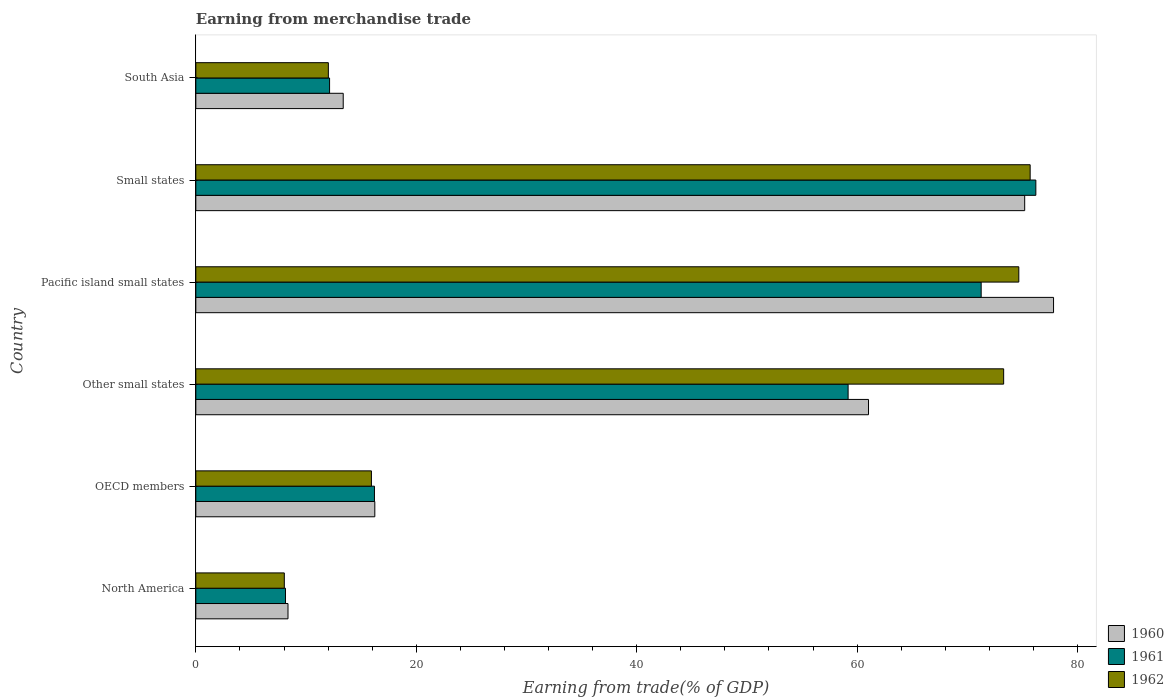How many groups of bars are there?
Give a very brief answer. 6. Are the number of bars per tick equal to the number of legend labels?
Ensure brevity in your answer.  Yes. How many bars are there on the 3rd tick from the top?
Ensure brevity in your answer.  3. What is the label of the 5th group of bars from the top?
Provide a succinct answer. OECD members. In how many cases, is the number of bars for a given country not equal to the number of legend labels?
Your answer should be very brief. 0. What is the earnings from trade in 1960 in North America?
Ensure brevity in your answer.  8.36. Across all countries, what is the maximum earnings from trade in 1962?
Keep it short and to the point. 75.7. Across all countries, what is the minimum earnings from trade in 1962?
Keep it short and to the point. 8.03. In which country was the earnings from trade in 1960 maximum?
Make the answer very short. Pacific island small states. In which country was the earnings from trade in 1960 minimum?
Offer a terse response. North America. What is the total earnings from trade in 1962 in the graph?
Offer a very short reply. 259.64. What is the difference between the earnings from trade in 1960 in North America and that in South Asia?
Ensure brevity in your answer.  -5.01. What is the difference between the earnings from trade in 1962 in Small states and the earnings from trade in 1960 in OECD members?
Provide a succinct answer. 59.46. What is the average earnings from trade in 1962 per country?
Offer a terse response. 43.27. What is the difference between the earnings from trade in 1960 and earnings from trade in 1961 in North America?
Your response must be concise. 0.23. In how many countries, is the earnings from trade in 1960 greater than 72 %?
Make the answer very short. 2. What is the ratio of the earnings from trade in 1962 in North America to that in South Asia?
Your answer should be very brief. 0.67. Is the earnings from trade in 1960 in Other small states less than that in South Asia?
Make the answer very short. No. What is the difference between the highest and the second highest earnings from trade in 1962?
Ensure brevity in your answer.  1.03. What is the difference between the highest and the lowest earnings from trade in 1960?
Give a very brief answer. 69.46. In how many countries, is the earnings from trade in 1962 greater than the average earnings from trade in 1962 taken over all countries?
Make the answer very short. 3. Is the sum of the earnings from trade in 1961 in Small states and South Asia greater than the maximum earnings from trade in 1962 across all countries?
Offer a terse response. Yes. What does the 3rd bar from the top in Pacific island small states represents?
Give a very brief answer. 1960. What is the difference between two consecutive major ticks on the X-axis?
Give a very brief answer. 20. Does the graph contain grids?
Provide a short and direct response. No. Where does the legend appear in the graph?
Make the answer very short. Bottom right. How many legend labels are there?
Give a very brief answer. 3. What is the title of the graph?
Your answer should be very brief. Earning from merchandise trade. What is the label or title of the X-axis?
Give a very brief answer. Earning from trade(% of GDP). What is the Earning from trade(% of GDP) of 1960 in North America?
Your response must be concise. 8.36. What is the Earning from trade(% of GDP) in 1961 in North America?
Offer a very short reply. 8.13. What is the Earning from trade(% of GDP) of 1962 in North America?
Make the answer very short. 8.03. What is the Earning from trade(% of GDP) of 1960 in OECD members?
Give a very brief answer. 16.24. What is the Earning from trade(% of GDP) in 1961 in OECD members?
Ensure brevity in your answer.  16.21. What is the Earning from trade(% of GDP) of 1962 in OECD members?
Give a very brief answer. 15.93. What is the Earning from trade(% of GDP) in 1960 in Other small states?
Make the answer very short. 61.03. What is the Earning from trade(% of GDP) of 1961 in Other small states?
Offer a terse response. 59.18. What is the Earning from trade(% of GDP) in 1962 in Other small states?
Ensure brevity in your answer.  73.29. What is the Earning from trade(% of GDP) of 1960 in Pacific island small states?
Provide a succinct answer. 77.82. What is the Earning from trade(% of GDP) of 1961 in Pacific island small states?
Ensure brevity in your answer.  71.25. What is the Earning from trade(% of GDP) in 1962 in Pacific island small states?
Make the answer very short. 74.67. What is the Earning from trade(% of GDP) of 1960 in Small states?
Keep it short and to the point. 75.2. What is the Earning from trade(% of GDP) of 1961 in Small states?
Provide a short and direct response. 76.21. What is the Earning from trade(% of GDP) of 1962 in Small states?
Your answer should be compact. 75.7. What is the Earning from trade(% of GDP) in 1960 in South Asia?
Offer a terse response. 13.37. What is the Earning from trade(% of GDP) of 1961 in South Asia?
Give a very brief answer. 12.14. What is the Earning from trade(% of GDP) of 1962 in South Asia?
Your response must be concise. 12.02. Across all countries, what is the maximum Earning from trade(% of GDP) in 1960?
Make the answer very short. 77.82. Across all countries, what is the maximum Earning from trade(% of GDP) in 1961?
Offer a very short reply. 76.21. Across all countries, what is the maximum Earning from trade(% of GDP) of 1962?
Offer a very short reply. 75.7. Across all countries, what is the minimum Earning from trade(% of GDP) of 1960?
Offer a terse response. 8.36. Across all countries, what is the minimum Earning from trade(% of GDP) in 1961?
Offer a terse response. 8.13. Across all countries, what is the minimum Earning from trade(% of GDP) in 1962?
Ensure brevity in your answer.  8.03. What is the total Earning from trade(% of GDP) of 1960 in the graph?
Ensure brevity in your answer.  252.03. What is the total Earning from trade(% of GDP) of 1961 in the graph?
Provide a short and direct response. 243.12. What is the total Earning from trade(% of GDP) in 1962 in the graph?
Your answer should be very brief. 259.64. What is the difference between the Earning from trade(% of GDP) in 1960 in North America and that in OECD members?
Give a very brief answer. -7.88. What is the difference between the Earning from trade(% of GDP) in 1961 in North America and that in OECD members?
Provide a succinct answer. -8.07. What is the difference between the Earning from trade(% of GDP) in 1962 in North America and that in OECD members?
Your answer should be compact. -7.9. What is the difference between the Earning from trade(% of GDP) of 1960 in North America and that in Other small states?
Provide a short and direct response. -52.67. What is the difference between the Earning from trade(% of GDP) of 1961 in North America and that in Other small states?
Your response must be concise. -51.05. What is the difference between the Earning from trade(% of GDP) of 1962 in North America and that in Other small states?
Provide a succinct answer. -65.27. What is the difference between the Earning from trade(% of GDP) of 1960 in North America and that in Pacific island small states?
Your answer should be very brief. -69.46. What is the difference between the Earning from trade(% of GDP) in 1961 in North America and that in Pacific island small states?
Your answer should be very brief. -63.12. What is the difference between the Earning from trade(% of GDP) of 1962 in North America and that in Pacific island small states?
Keep it short and to the point. -66.64. What is the difference between the Earning from trade(% of GDP) in 1960 in North America and that in Small states?
Keep it short and to the point. -66.84. What is the difference between the Earning from trade(% of GDP) in 1961 in North America and that in Small states?
Keep it short and to the point. -68.08. What is the difference between the Earning from trade(% of GDP) of 1962 in North America and that in Small states?
Make the answer very short. -67.67. What is the difference between the Earning from trade(% of GDP) of 1960 in North America and that in South Asia?
Your answer should be very brief. -5.01. What is the difference between the Earning from trade(% of GDP) of 1961 in North America and that in South Asia?
Offer a very short reply. -4. What is the difference between the Earning from trade(% of GDP) in 1962 in North America and that in South Asia?
Provide a succinct answer. -4. What is the difference between the Earning from trade(% of GDP) in 1960 in OECD members and that in Other small states?
Provide a short and direct response. -44.79. What is the difference between the Earning from trade(% of GDP) of 1961 in OECD members and that in Other small states?
Make the answer very short. -42.98. What is the difference between the Earning from trade(% of GDP) in 1962 in OECD members and that in Other small states?
Provide a short and direct response. -57.36. What is the difference between the Earning from trade(% of GDP) in 1960 in OECD members and that in Pacific island small states?
Your answer should be compact. -61.58. What is the difference between the Earning from trade(% of GDP) of 1961 in OECD members and that in Pacific island small states?
Your response must be concise. -55.05. What is the difference between the Earning from trade(% of GDP) in 1962 in OECD members and that in Pacific island small states?
Ensure brevity in your answer.  -58.74. What is the difference between the Earning from trade(% of GDP) in 1960 in OECD members and that in Small states?
Your answer should be compact. -58.96. What is the difference between the Earning from trade(% of GDP) in 1961 in OECD members and that in Small states?
Offer a very short reply. -60.01. What is the difference between the Earning from trade(% of GDP) in 1962 in OECD members and that in Small states?
Your response must be concise. -59.77. What is the difference between the Earning from trade(% of GDP) in 1960 in OECD members and that in South Asia?
Provide a short and direct response. 2.87. What is the difference between the Earning from trade(% of GDP) in 1961 in OECD members and that in South Asia?
Give a very brief answer. 4.07. What is the difference between the Earning from trade(% of GDP) in 1962 in OECD members and that in South Asia?
Offer a terse response. 3.91. What is the difference between the Earning from trade(% of GDP) in 1960 in Other small states and that in Pacific island small states?
Your response must be concise. -16.79. What is the difference between the Earning from trade(% of GDP) in 1961 in Other small states and that in Pacific island small states?
Offer a very short reply. -12.07. What is the difference between the Earning from trade(% of GDP) of 1962 in Other small states and that in Pacific island small states?
Provide a succinct answer. -1.37. What is the difference between the Earning from trade(% of GDP) in 1960 in Other small states and that in Small states?
Your answer should be very brief. -14.17. What is the difference between the Earning from trade(% of GDP) of 1961 in Other small states and that in Small states?
Provide a short and direct response. -17.03. What is the difference between the Earning from trade(% of GDP) of 1962 in Other small states and that in Small states?
Give a very brief answer. -2.4. What is the difference between the Earning from trade(% of GDP) in 1960 in Other small states and that in South Asia?
Offer a very short reply. 47.66. What is the difference between the Earning from trade(% of GDP) in 1961 in Other small states and that in South Asia?
Provide a short and direct response. 47.05. What is the difference between the Earning from trade(% of GDP) of 1962 in Other small states and that in South Asia?
Provide a succinct answer. 61.27. What is the difference between the Earning from trade(% of GDP) of 1960 in Pacific island small states and that in Small states?
Your answer should be compact. 2.62. What is the difference between the Earning from trade(% of GDP) in 1961 in Pacific island small states and that in Small states?
Make the answer very short. -4.96. What is the difference between the Earning from trade(% of GDP) of 1962 in Pacific island small states and that in Small states?
Your answer should be very brief. -1.03. What is the difference between the Earning from trade(% of GDP) in 1960 in Pacific island small states and that in South Asia?
Your response must be concise. 64.45. What is the difference between the Earning from trade(% of GDP) in 1961 in Pacific island small states and that in South Asia?
Offer a terse response. 59.12. What is the difference between the Earning from trade(% of GDP) in 1962 in Pacific island small states and that in South Asia?
Your answer should be very brief. 62.64. What is the difference between the Earning from trade(% of GDP) of 1960 in Small states and that in South Asia?
Offer a terse response. 61.83. What is the difference between the Earning from trade(% of GDP) of 1961 in Small states and that in South Asia?
Keep it short and to the point. 64.08. What is the difference between the Earning from trade(% of GDP) of 1962 in Small states and that in South Asia?
Offer a very short reply. 63.67. What is the difference between the Earning from trade(% of GDP) in 1960 in North America and the Earning from trade(% of GDP) in 1961 in OECD members?
Offer a terse response. -7.84. What is the difference between the Earning from trade(% of GDP) in 1960 in North America and the Earning from trade(% of GDP) in 1962 in OECD members?
Your answer should be compact. -7.57. What is the difference between the Earning from trade(% of GDP) in 1961 in North America and the Earning from trade(% of GDP) in 1962 in OECD members?
Keep it short and to the point. -7.8. What is the difference between the Earning from trade(% of GDP) in 1960 in North America and the Earning from trade(% of GDP) in 1961 in Other small states?
Your answer should be compact. -50.82. What is the difference between the Earning from trade(% of GDP) in 1960 in North America and the Earning from trade(% of GDP) in 1962 in Other small states?
Provide a succinct answer. -64.93. What is the difference between the Earning from trade(% of GDP) in 1961 in North America and the Earning from trade(% of GDP) in 1962 in Other small states?
Provide a succinct answer. -65.16. What is the difference between the Earning from trade(% of GDP) in 1960 in North America and the Earning from trade(% of GDP) in 1961 in Pacific island small states?
Make the answer very short. -62.89. What is the difference between the Earning from trade(% of GDP) of 1960 in North America and the Earning from trade(% of GDP) of 1962 in Pacific island small states?
Your answer should be compact. -66.31. What is the difference between the Earning from trade(% of GDP) in 1961 in North America and the Earning from trade(% of GDP) in 1962 in Pacific island small states?
Keep it short and to the point. -66.53. What is the difference between the Earning from trade(% of GDP) of 1960 in North America and the Earning from trade(% of GDP) of 1961 in Small states?
Offer a very short reply. -67.85. What is the difference between the Earning from trade(% of GDP) in 1960 in North America and the Earning from trade(% of GDP) in 1962 in Small states?
Provide a short and direct response. -67.33. What is the difference between the Earning from trade(% of GDP) in 1961 in North America and the Earning from trade(% of GDP) in 1962 in Small states?
Give a very brief answer. -67.56. What is the difference between the Earning from trade(% of GDP) in 1960 in North America and the Earning from trade(% of GDP) in 1961 in South Asia?
Your answer should be compact. -3.77. What is the difference between the Earning from trade(% of GDP) of 1960 in North America and the Earning from trade(% of GDP) of 1962 in South Asia?
Offer a very short reply. -3.66. What is the difference between the Earning from trade(% of GDP) of 1961 in North America and the Earning from trade(% of GDP) of 1962 in South Asia?
Keep it short and to the point. -3.89. What is the difference between the Earning from trade(% of GDP) in 1960 in OECD members and the Earning from trade(% of GDP) in 1961 in Other small states?
Make the answer very short. -42.94. What is the difference between the Earning from trade(% of GDP) of 1960 in OECD members and the Earning from trade(% of GDP) of 1962 in Other small states?
Offer a terse response. -57.05. What is the difference between the Earning from trade(% of GDP) in 1961 in OECD members and the Earning from trade(% of GDP) in 1962 in Other small states?
Your answer should be compact. -57.09. What is the difference between the Earning from trade(% of GDP) in 1960 in OECD members and the Earning from trade(% of GDP) in 1961 in Pacific island small states?
Keep it short and to the point. -55.01. What is the difference between the Earning from trade(% of GDP) of 1960 in OECD members and the Earning from trade(% of GDP) of 1962 in Pacific island small states?
Make the answer very short. -58.43. What is the difference between the Earning from trade(% of GDP) in 1961 in OECD members and the Earning from trade(% of GDP) in 1962 in Pacific island small states?
Ensure brevity in your answer.  -58.46. What is the difference between the Earning from trade(% of GDP) in 1960 in OECD members and the Earning from trade(% of GDP) in 1961 in Small states?
Make the answer very short. -59.97. What is the difference between the Earning from trade(% of GDP) of 1960 in OECD members and the Earning from trade(% of GDP) of 1962 in Small states?
Keep it short and to the point. -59.46. What is the difference between the Earning from trade(% of GDP) of 1961 in OECD members and the Earning from trade(% of GDP) of 1962 in Small states?
Offer a very short reply. -59.49. What is the difference between the Earning from trade(% of GDP) of 1960 in OECD members and the Earning from trade(% of GDP) of 1961 in South Asia?
Provide a short and direct response. 4.1. What is the difference between the Earning from trade(% of GDP) of 1960 in OECD members and the Earning from trade(% of GDP) of 1962 in South Asia?
Your answer should be compact. 4.22. What is the difference between the Earning from trade(% of GDP) of 1961 in OECD members and the Earning from trade(% of GDP) of 1962 in South Asia?
Provide a succinct answer. 4.18. What is the difference between the Earning from trade(% of GDP) of 1960 in Other small states and the Earning from trade(% of GDP) of 1961 in Pacific island small states?
Your answer should be compact. -10.22. What is the difference between the Earning from trade(% of GDP) of 1960 in Other small states and the Earning from trade(% of GDP) of 1962 in Pacific island small states?
Your answer should be very brief. -13.64. What is the difference between the Earning from trade(% of GDP) in 1961 in Other small states and the Earning from trade(% of GDP) in 1962 in Pacific island small states?
Your answer should be compact. -15.49. What is the difference between the Earning from trade(% of GDP) of 1960 in Other small states and the Earning from trade(% of GDP) of 1961 in Small states?
Give a very brief answer. -15.18. What is the difference between the Earning from trade(% of GDP) in 1960 in Other small states and the Earning from trade(% of GDP) in 1962 in Small states?
Your answer should be very brief. -14.67. What is the difference between the Earning from trade(% of GDP) of 1961 in Other small states and the Earning from trade(% of GDP) of 1962 in Small states?
Provide a short and direct response. -16.52. What is the difference between the Earning from trade(% of GDP) of 1960 in Other small states and the Earning from trade(% of GDP) of 1961 in South Asia?
Make the answer very short. 48.9. What is the difference between the Earning from trade(% of GDP) of 1960 in Other small states and the Earning from trade(% of GDP) of 1962 in South Asia?
Your answer should be compact. 49.01. What is the difference between the Earning from trade(% of GDP) in 1961 in Other small states and the Earning from trade(% of GDP) in 1962 in South Asia?
Your answer should be compact. 47.16. What is the difference between the Earning from trade(% of GDP) in 1960 in Pacific island small states and the Earning from trade(% of GDP) in 1961 in Small states?
Give a very brief answer. 1.61. What is the difference between the Earning from trade(% of GDP) in 1960 in Pacific island small states and the Earning from trade(% of GDP) in 1962 in Small states?
Make the answer very short. 2.12. What is the difference between the Earning from trade(% of GDP) in 1961 in Pacific island small states and the Earning from trade(% of GDP) in 1962 in Small states?
Ensure brevity in your answer.  -4.44. What is the difference between the Earning from trade(% of GDP) of 1960 in Pacific island small states and the Earning from trade(% of GDP) of 1961 in South Asia?
Offer a very short reply. 65.68. What is the difference between the Earning from trade(% of GDP) of 1960 in Pacific island small states and the Earning from trade(% of GDP) of 1962 in South Asia?
Your answer should be compact. 65.8. What is the difference between the Earning from trade(% of GDP) in 1961 in Pacific island small states and the Earning from trade(% of GDP) in 1962 in South Asia?
Make the answer very short. 59.23. What is the difference between the Earning from trade(% of GDP) of 1960 in Small states and the Earning from trade(% of GDP) of 1961 in South Asia?
Offer a very short reply. 63.07. What is the difference between the Earning from trade(% of GDP) of 1960 in Small states and the Earning from trade(% of GDP) of 1962 in South Asia?
Your answer should be very brief. 63.18. What is the difference between the Earning from trade(% of GDP) in 1961 in Small states and the Earning from trade(% of GDP) in 1962 in South Asia?
Provide a short and direct response. 64.19. What is the average Earning from trade(% of GDP) of 1960 per country?
Provide a short and direct response. 42. What is the average Earning from trade(% of GDP) in 1961 per country?
Your response must be concise. 40.52. What is the average Earning from trade(% of GDP) of 1962 per country?
Offer a terse response. 43.27. What is the difference between the Earning from trade(% of GDP) in 1960 and Earning from trade(% of GDP) in 1961 in North America?
Make the answer very short. 0.23. What is the difference between the Earning from trade(% of GDP) of 1960 and Earning from trade(% of GDP) of 1962 in North America?
Provide a succinct answer. 0.33. What is the difference between the Earning from trade(% of GDP) in 1961 and Earning from trade(% of GDP) in 1962 in North America?
Provide a succinct answer. 0.11. What is the difference between the Earning from trade(% of GDP) of 1960 and Earning from trade(% of GDP) of 1961 in OECD members?
Offer a terse response. 0.03. What is the difference between the Earning from trade(% of GDP) in 1960 and Earning from trade(% of GDP) in 1962 in OECD members?
Give a very brief answer. 0.31. What is the difference between the Earning from trade(% of GDP) in 1961 and Earning from trade(% of GDP) in 1962 in OECD members?
Offer a very short reply. 0.28. What is the difference between the Earning from trade(% of GDP) of 1960 and Earning from trade(% of GDP) of 1961 in Other small states?
Keep it short and to the point. 1.85. What is the difference between the Earning from trade(% of GDP) of 1960 and Earning from trade(% of GDP) of 1962 in Other small states?
Offer a terse response. -12.26. What is the difference between the Earning from trade(% of GDP) in 1961 and Earning from trade(% of GDP) in 1962 in Other small states?
Your answer should be compact. -14.11. What is the difference between the Earning from trade(% of GDP) in 1960 and Earning from trade(% of GDP) in 1961 in Pacific island small states?
Provide a succinct answer. 6.57. What is the difference between the Earning from trade(% of GDP) in 1960 and Earning from trade(% of GDP) in 1962 in Pacific island small states?
Provide a short and direct response. 3.15. What is the difference between the Earning from trade(% of GDP) of 1961 and Earning from trade(% of GDP) of 1962 in Pacific island small states?
Keep it short and to the point. -3.42. What is the difference between the Earning from trade(% of GDP) of 1960 and Earning from trade(% of GDP) of 1961 in Small states?
Your answer should be very brief. -1.01. What is the difference between the Earning from trade(% of GDP) in 1960 and Earning from trade(% of GDP) in 1962 in Small states?
Offer a terse response. -0.5. What is the difference between the Earning from trade(% of GDP) in 1961 and Earning from trade(% of GDP) in 1962 in Small states?
Make the answer very short. 0.52. What is the difference between the Earning from trade(% of GDP) in 1960 and Earning from trade(% of GDP) in 1961 in South Asia?
Provide a short and direct response. 1.24. What is the difference between the Earning from trade(% of GDP) in 1960 and Earning from trade(% of GDP) in 1962 in South Asia?
Offer a terse response. 1.35. What is the difference between the Earning from trade(% of GDP) of 1961 and Earning from trade(% of GDP) of 1962 in South Asia?
Ensure brevity in your answer.  0.11. What is the ratio of the Earning from trade(% of GDP) of 1960 in North America to that in OECD members?
Your answer should be compact. 0.52. What is the ratio of the Earning from trade(% of GDP) of 1961 in North America to that in OECD members?
Keep it short and to the point. 0.5. What is the ratio of the Earning from trade(% of GDP) in 1962 in North America to that in OECD members?
Your response must be concise. 0.5. What is the ratio of the Earning from trade(% of GDP) in 1960 in North America to that in Other small states?
Your answer should be very brief. 0.14. What is the ratio of the Earning from trade(% of GDP) in 1961 in North America to that in Other small states?
Your answer should be compact. 0.14. What is the ratio of the Earning from trade(% of GDP) in 1962 in North America to that in Other small states?
Keep it short and to the point. 0.11. What is the ratio of the Earning from trade(% of GDP) of 1960 in North America to that in Pacific island small states?
Your answer should be compact. 0.11. What is the ratio of the Earning from trade(% of GDP) in 1961 in North America to that in Pacific island small states?
Your response must be concise. 0.11. What is the ratio of the Earning from trade(% of GDP) in 1962 in North America to that in Pacific island small states?
Offer a terse response. 0.11. What is the ratio of the Earning from trade(% of GDP) in 1960 in North America to that in Small states?
Provide a succinct answer. 0.11. What is the ratio of the Earning from trade(% of GDP) in 1961 in North America to that in Small states?
Give a very brief answer. 0.11. What is the ratio of the Earning from trade(% of GDP) in 1962 in North America to that in Small states?
Provide a succinct answer. 0.11. What is the ratio of the Earning from trade(% of GDP) in 1960 in North America to that in South Asia?
Keep it short and to the point. 0.63. What is the ratio of the Earning from trade(% of GDP) of 1961 in North America to that in South Asia?
Offer a terse response. 0.67. What is the ratio of the Earning from trade(% of GDP) in 1962 in North America to that in South Asia?
Your answer should be compact. 0.67. What is the ratio of the Earning from trade(% of GDP) in 1960 in OECD members to that in Other small states?
Offer a terse response. 0.27. What is the ratio of the Earning from trade(% of GDP) of 1961 in OECD members to that in Other small states?
Offer a very short reply. 0.27. What is the ratio of the Earning from trade(% of GDP) in 1962 in OECD members to that in Other small states?
Offer a terse response. 0.22. What is the ratio of the Earning from trade(% of GDP) in 1960 in OECD members to that in Pacific island small states?
Keep it short and to the point. 0.21. What is the ratio of the Earning from trade(% of GDP) in 1961 in OECD members to that in Pacific island small states?
Give a very brief answer. 0.23. What is the ratio of the Earning from trade(% of GDP) in 1962 in OECD members to that in Pacific island small states?
Ensure brevity in your answer.  0.21. What is the ratio of the Earning from trade(% of GDP) in 1960 in OECD members to that in Small states?
Provide a succinct answer. 0.22. What is the ratio of the Earning from trade(% of GDP) of 1961 in OECD members to that in Small states?
Your answer should be very brief. 0.21. What is the ratio of the Earning from trade(% of GDP) in 1962 in OECD members to that in Small states?
Offer a very short reply. 0.21. What is the ratio of the Earning from trade(% of GDP) of 1960 in OECD members to that in South Asia?
Give a very brief answer. 1.21. What is the ratio of the Earning from trade(% of GDP) of 1961 in OECD members to that in South Asia?
Give a very brief answer. 1.34. What is the ratio of the Earning from trade(% of GDP) in 1962 in OECD members to that in South Asia?
Ensure brevity in your answer.  1.32. What is the ratio of the Earning from trade(% of GDP) in 1960 in Other small states to that in Pacific island small states?
Give a very brief answer. 0.78. What is the ratio of the Earning from trade(% of GDP) in 1961 in Other small states to that in Pacific island small states?
Your response must be concise. 0.83. What is the ratio of the Earning from trade(% of GDP) in 1962 in Other small states to that in Pacific island small states?
Offer a very short reply. 0.98. What is the ratio of the Earning from trade(% of GDP) in 1960 in Other small states to that in Small states?
Give a very brief answer. 0.81. What is the ratio of the Earning from trade(% of GDP) of 1961 in Other small states to that in Small states?
Your answer should be compact. 0.78. What is the ratio of the Earning from trade(% of GDP) of 1962 in Other small states to that in Small states?
Provide a short and direct response. 0.97. What is the ratio of the Earning from trade(% of GDP) in 1960 in Other small states to that in South Asia?
Provide a short and direct response. 4.56. What is the ratio of the Earning from trade(% of GDP) in 1961 in Other small states to that in South Asia?
Your response must be concise. 4.88. What is the ratio of the Earning from trade(% of GDP) in 1962 in Other small states to that in South Asia?
Offer a very short reply. 6.1. What is the ratio of the Earning from trade(% of GDP) of 1960 in Pacific island small states to that in Small states?
Your response must be concise. 1.03. What is the ratio of the Earning from trade(% of GDP) in 1961 in Pacific island small states to that in Small states?
Provide a short and direct response. 0.93. What is the ratio of the Earning from trade(% of GDP) in 1962 in Pacific island small states to that in Small states?
Your response must be concise. 0.99. What is the ratio of the Earning from trade(% of GDP) of 1960 in Pacific island small states to that in South Asia?
Offer a very short reply. 5.82. What is the ratio of the Earning from trade(% of GDP) in 1961 in Pacific island small states to that in South Asia?
Your response must be concise. 5.87. What is the ratio of the Earning from trade(% of GDP) of 1962 in Pacific island small states to that in South Asia?
Give a very brief answer. 6.21. What is the ratio of the Earning from trade(% of GDP) of 1960 in Small states to that in South Asia?
Offer a terse response. 5.62. What is the ratio of the Earning from trade(% of GDP) in 1961 in Small states to that in South Asia?
Provide a short and direct response. 6.28. What is the ratio of the Earning from trade(% of GDP) in 1962 in Small states to that in South Asia?
Your answer should be compact. 6.3. What is the difference between the highest and the second highest Earning from trade(% of GDP) of 1960?
Ensure brevity in your answer.  2.62. What is the difference between the highest and the second highest Earning from trade(% of GDP) of 1961?
Offer a terse response. 4.96. What is the difference between the highest and the second highest Earning from trade(% of GDP) in 1962?
Give a very brief answer. 1.03. What is the difference between the highest and the lowest Earning from trade(% of GDP) in 1960?
Give a very brief answer. 69.46. What is the difference between the highest and the lowest Earning from trade(% of GDP) in 1961?
Offer a very short reply. 68.08. What is the difference between the highest and the lowest Earning from trade(% of GDP) of 1962?
Give a very brief answer. 67.67. 